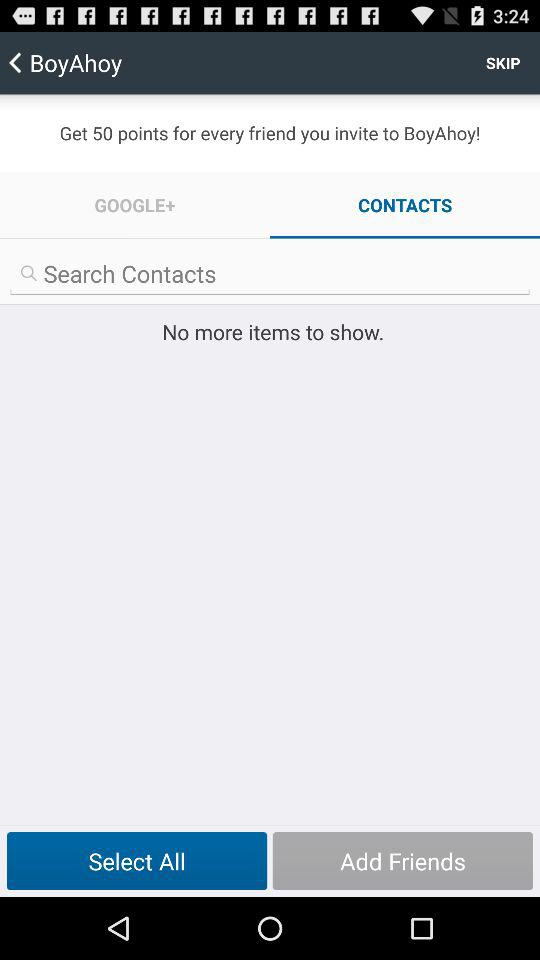How many more points do I get for inviting a friend than for searching for a contact?
Answer the question using a single word or phrase. 50 